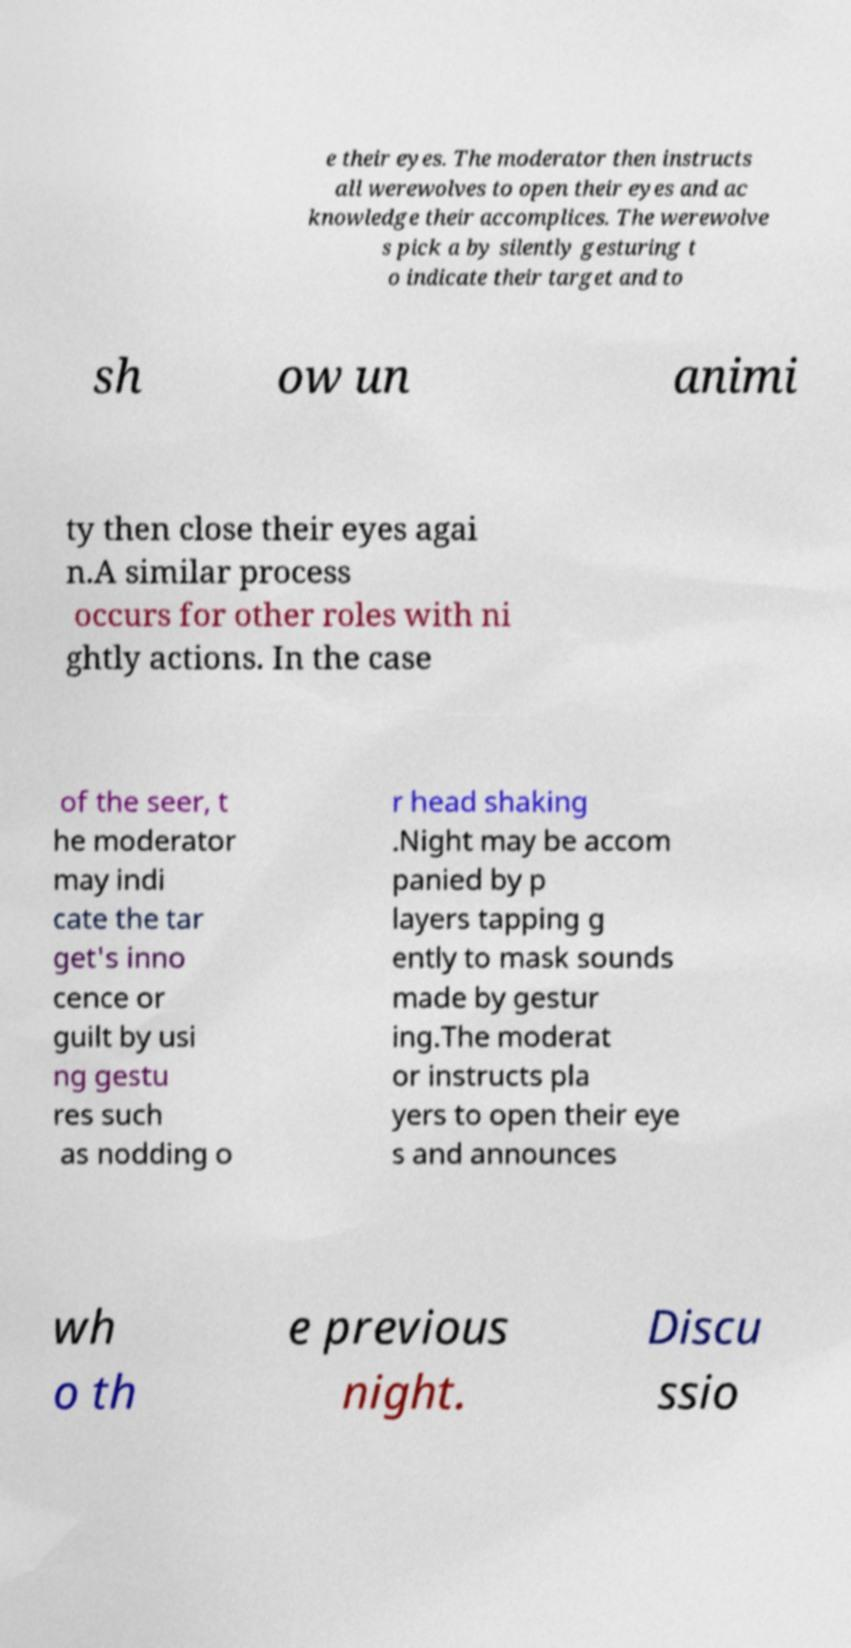Can you accurately transcribe the text from the provided image for me? e their eyes. The moderator then instructs all werewolves to open their eyes and ac knowledge their accomplices. The werewolve s pick a by silently gesturing t o indicate their target and to sh ow un animi ty then close their eyes agai n.A similar process occurs for other roles with ni ghtly actions. In the case of the seer, t he moderator may indi cate the tar get's inno cence or guilt by usi ng gestu res such as nodding o r head shaking .Night may be accom panied by p layers tapping g ently to mask sounds made by gestur ing.The moderat or instructs pla yers to open their eye s and announces wh o th e previous night. Discu ssio 